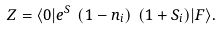Convert formula to latex. <formula><loc_0><loc_0><loc_500><loc_500>Z = { \langle 0 | } e ^ { S } \ ( 1 - n _ { i } ) \ ( 1 + S _ { i } ) { | F \rangle } .</formula> 